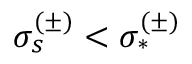<formula> <loc_0><loc_0><loc_500><loc_500>\sigma _ { s } ^ { ( \pm ) } < \sigma _ { * } ^ { ( \pm ) }</formula> 